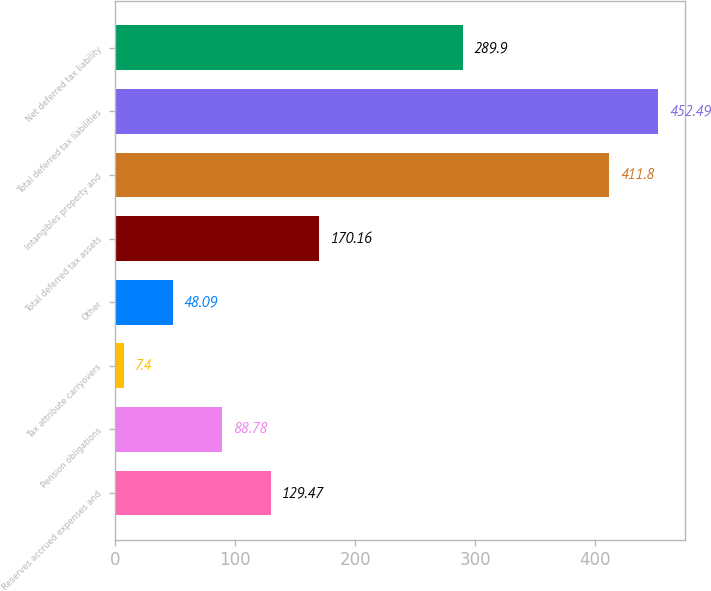<chart> <loc_0><loc_0><loc_500><loc_500><bar_chart><fcel>Reserves accrued expenses and<fcel>Pension obligations<fcel>Tax attribute carryovers<fcel>Other<fcel>Total deferred tax assets<fcel>Intangibles property and<fcel>Total deferred tax liabilities<fcel>Net deferred tax liability<nl><fcel>129.47<fcel>88.78<fcel>7.4<fcel>48.09<fcel>170.16<fcel>411.8<fcel>452.49<fcel>289.9<nl></chart> 